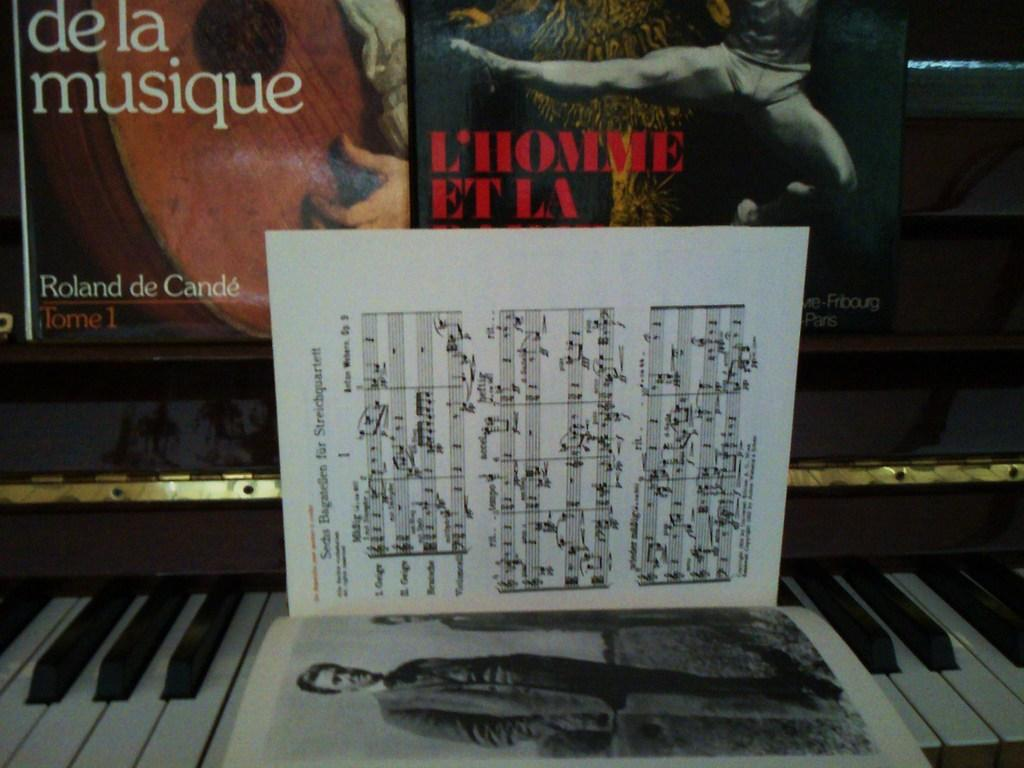What is the main object in the image? There is a piano in the image. What can be seen on the wall in the image? There are posters on the wall in the image. Can you identify any other objects in the image? Yes, there is a book visible in the image. What type of jewel is being sold at the market in the image? There is no market or jewel present in the image; it features a piano and posters on the wall. 